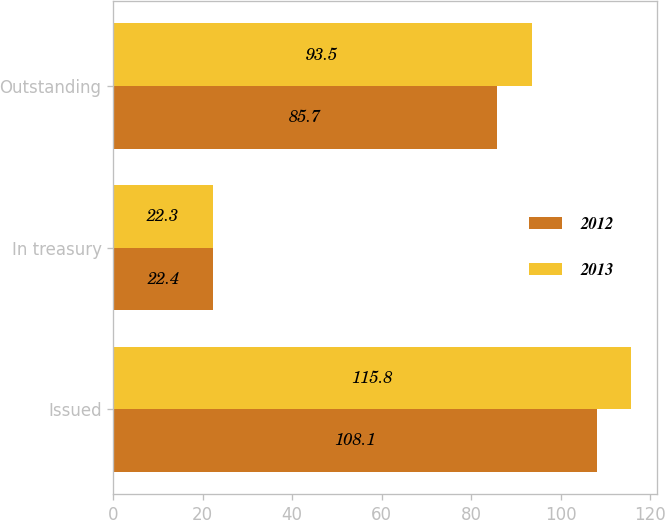Convert chart to OTSL. <chart><loc_0><loc_0><loc_500><loc_500><stacked_bar_chart><ecel><fcel>Issued<fcel>In treasury<fcel>Outstanding<nl><fcel>2012<fcel>108.1<fcel>22.4<fcel>85.7<nl><fcel>2013<fcel>115.8<fcel>22.3<fcel>93.5<nl></chart> 